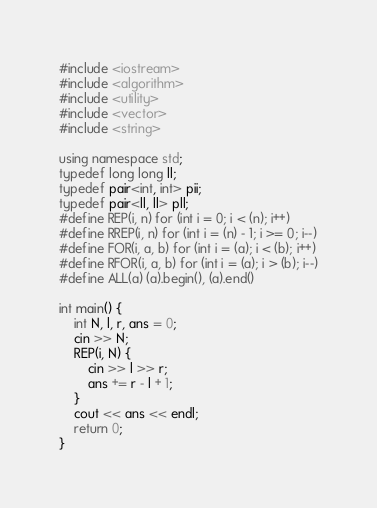Convert code to text. <code><loc_0><loc_0><loc_500><loc_500><_C++_>#include <iostream>
#include <algorithm>
#include <utility>
#include <vector>
#include <string>

using namespace std;
typedef long long ll;
typedef pair<int, int> pii;
typedef pair<ll, ll> pll;
#define REP(i, n) for (int i = 0; i < (n); i++)
#define RREP(i, n) for (int i = (n) - 1; i >= 0; i--)
#define FOR(i, a, b) for (int i = (a); i < (b); i++)
#define RFOR(i, a, b) for (int i = (a); i > (b); i--)
#define ALL(a) (a).begin(), (a).end()

int main() {
    int N, l, r, ans = 0;
    cin >> N;
    REP(i, N) {
        cin >> l >> r;
        ans += r - l + 1;
    }
    cout << ans << endl;
    return 0;
}</code> 